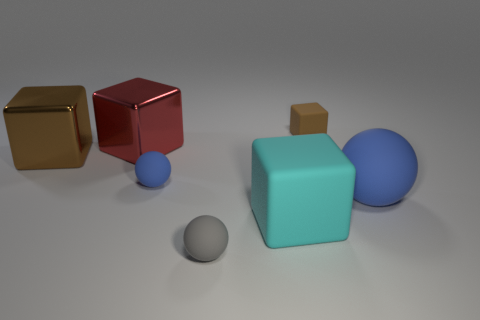Subtract all red metal blocks. How many blocks are left? 3 Subtract 2 cubes. How many cubes are left? 2 Subtract all brown blocks. How many blocks are left? 2 Subtract 0 green spheres. How many objects are left? 7 Subtract all cubes. How many objects are left? 3 Subtract all cyan blocks. Subtract all brown cylinders. How many blocks are left? 3 Subtract all brown balls. How many red cubes are left? 1 Subtract all blue objects. Subtract all red blocks. How many objects are left? 4 Add 1 small brown rubber objects. How many small brown rubber objects are left? 2 Add 3 big green matte cubes. How many big green matte cubes exist? 3 